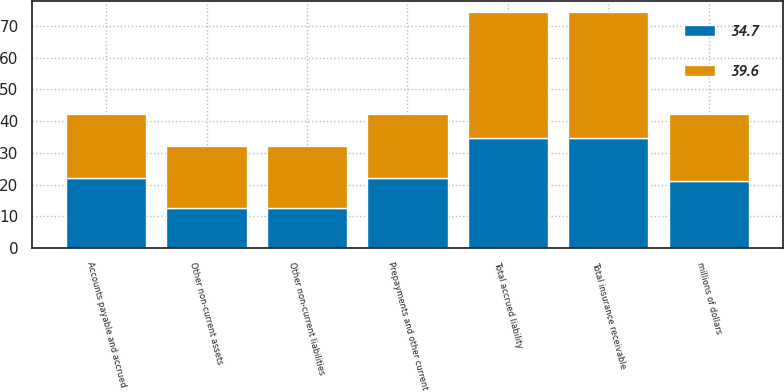Convert chart to OTSL. <chart><loc_0><loc_0><loc_500><loc_500><stacked_bar_chart><ecel><fcel>millions of dollars<fcel>Prepayments and other current<fcel>Other non-current assets<fcel>Total insurance receivable<fcel>Accounts payable and accrued<fcel>Other non-current liabilities<fcel>Total accrued liability<nl><fcel>34.7<fcel>21.1<fcel>22.1<fcel>12.6<fcel>34.7<fcel>22.1<fcel>12.6<fcel>34.7<nl><fcel>39.6<fcel>21.1<fcel>20.1<fcel>19.5<fcel>39.6<fcel>20.1<fcel>19.5<fcel>39.6<nl></chart> 